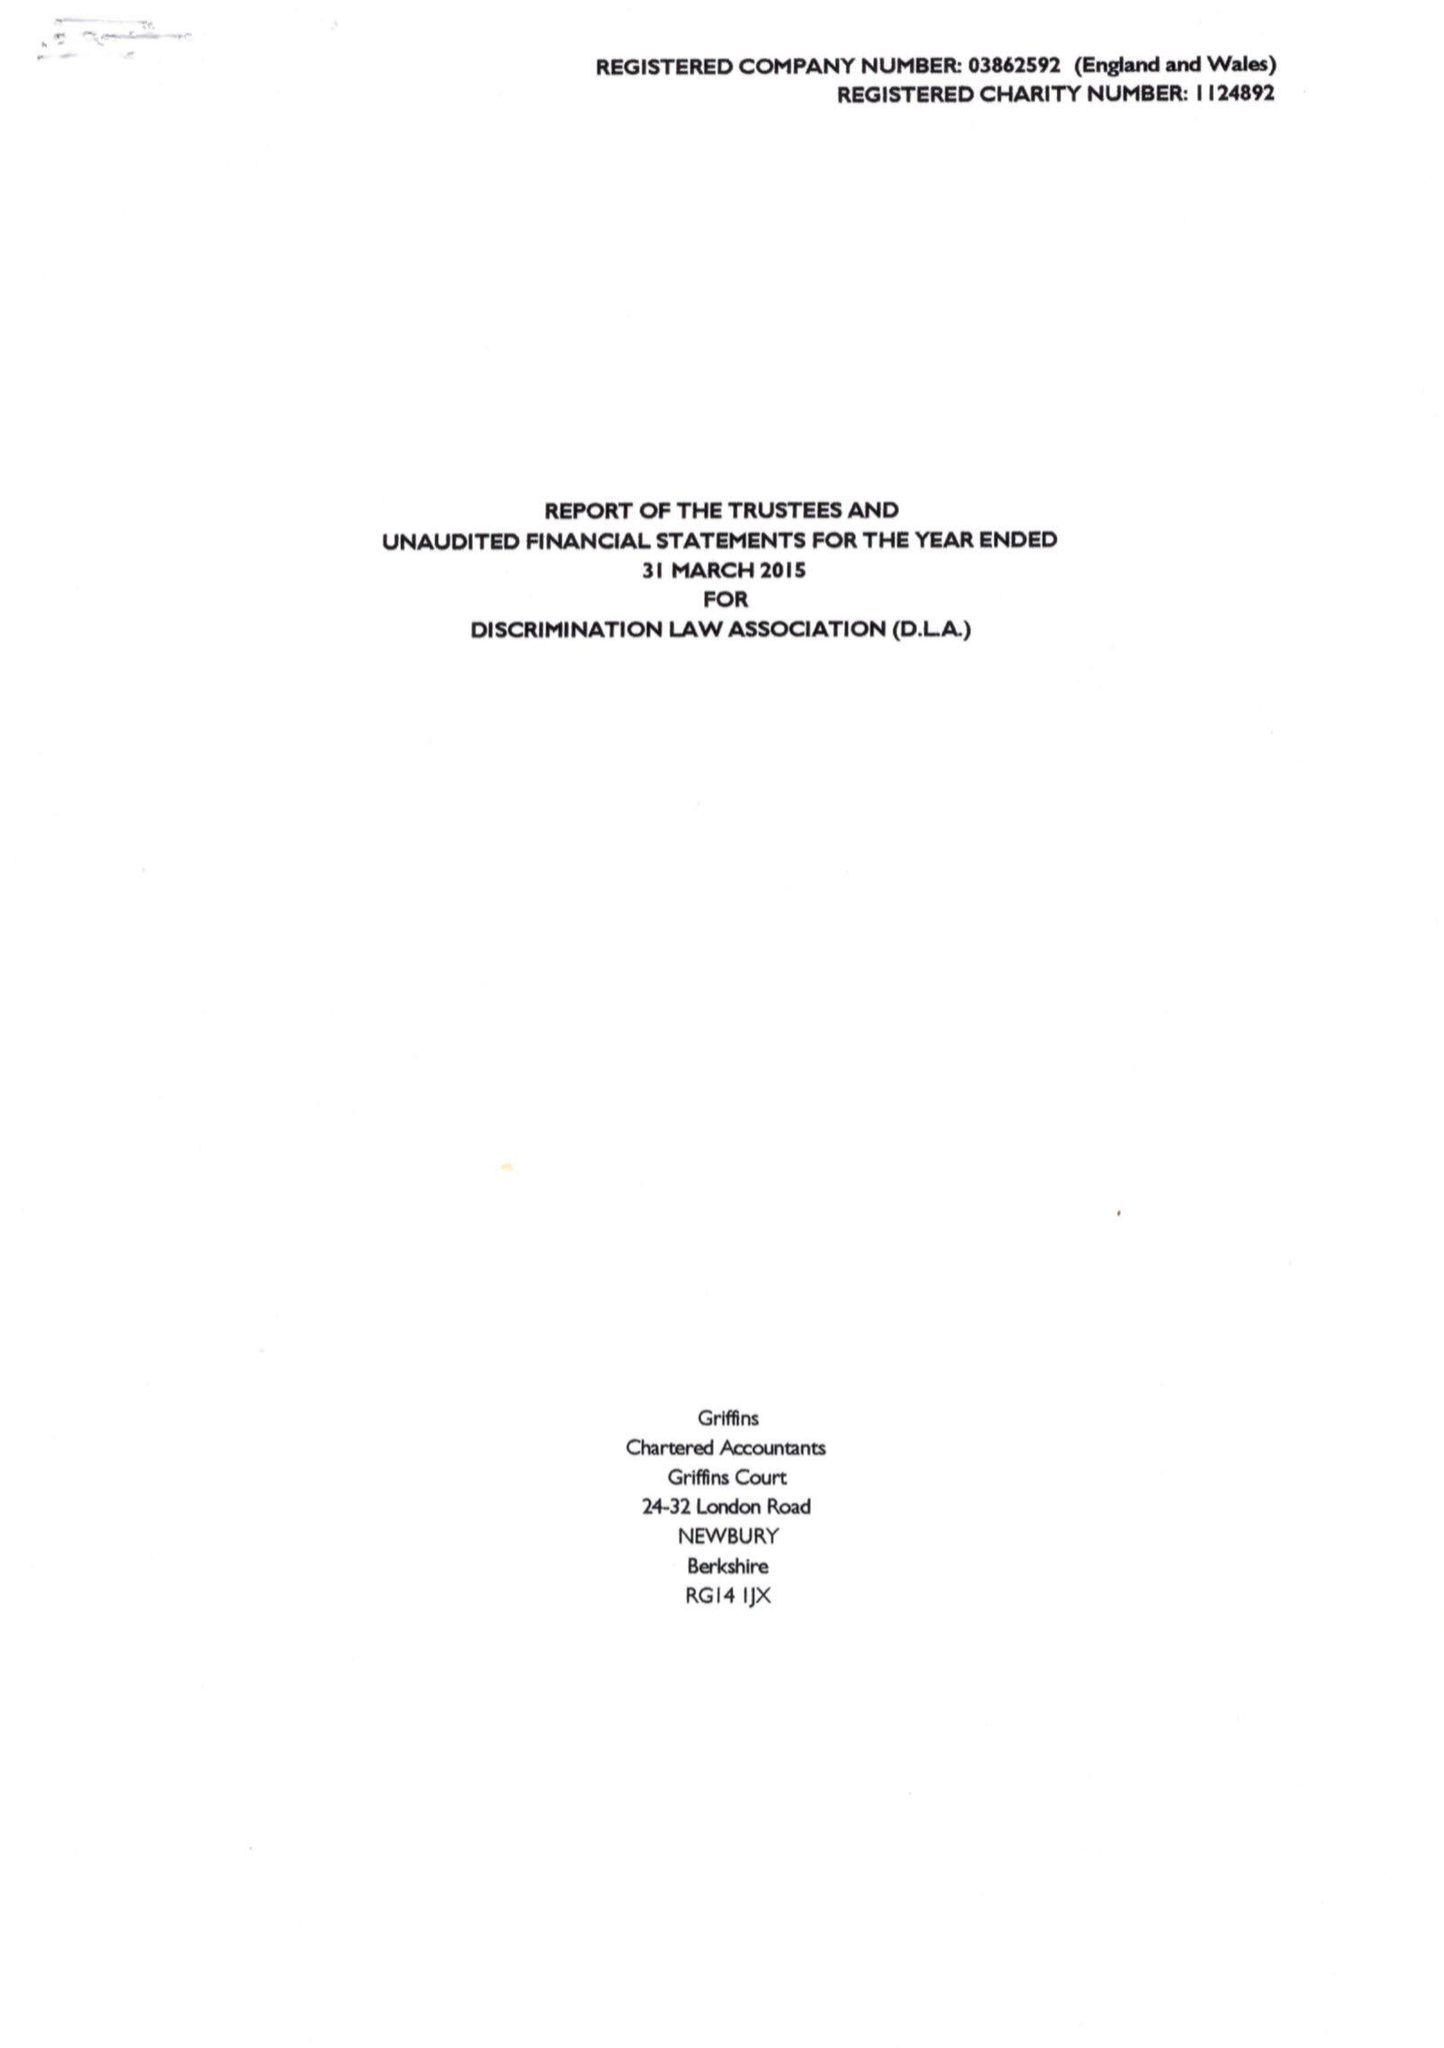What is the value for the report_date?
Answer the question using a single word or phrase. 2015-03-31 